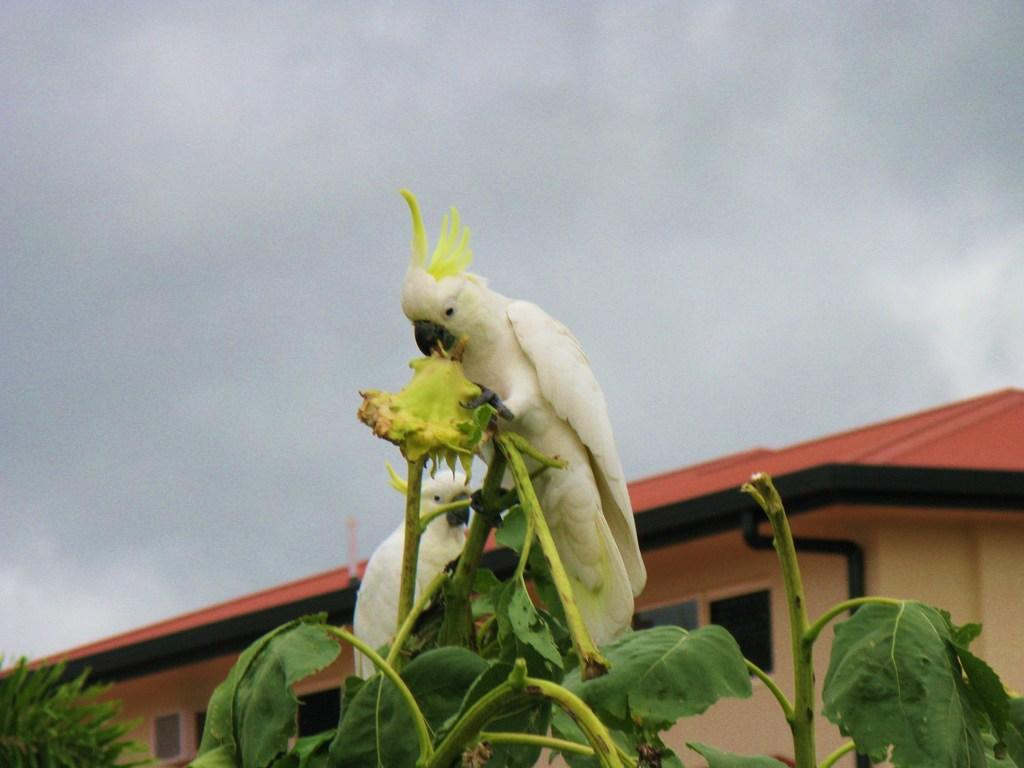What type of animals can be seen on the plants in the image? There are birds on the plants in the image. What structure can be seen in the background of the image? There is a house in the background of the image. What part of the natural environment is visible in the image? The sky is visible in the image. Where is the ant hiding in the image? There is no ant present in the image. What type of clothing is the tramp wearing in the image? There is no tramp present in the image. 